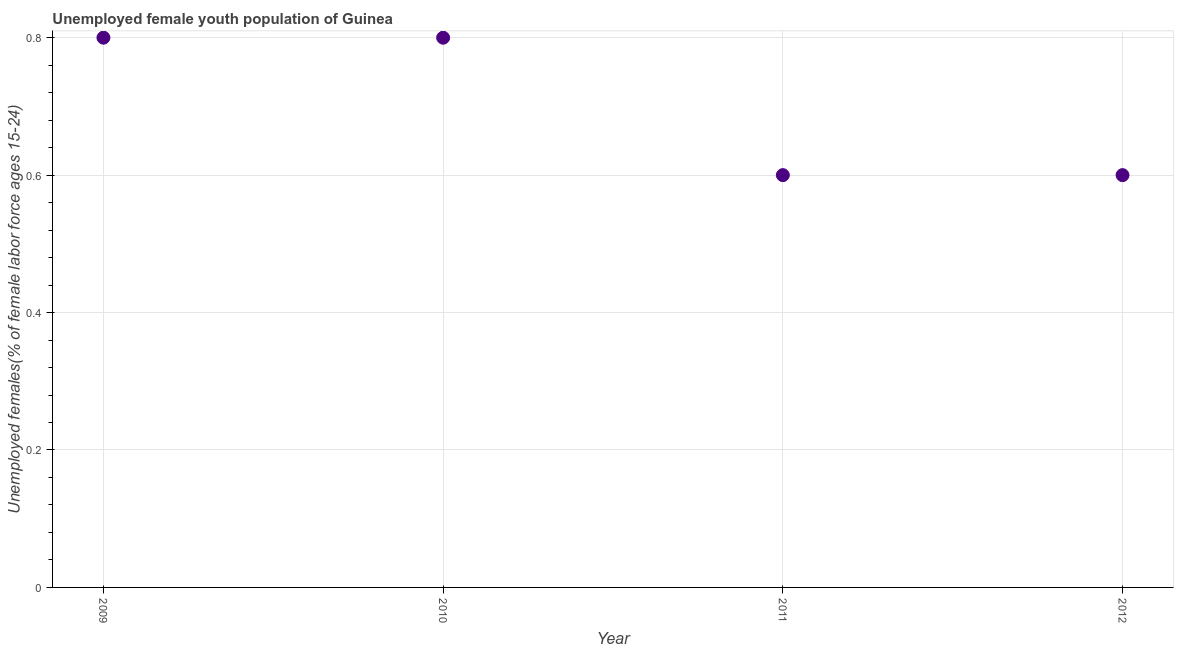What is the unemployed female youth in 2010?
Provide a short and direct response. 0.8. Across all years, what is the maximum unemployed female youth?
Your response must be concise. 0.8. Across all years, what is the minimum unemployed female youth?
Offer a terse response. 0.6. In which year was the unemployed female youth maximum?
Make the answer very short. 2009. In which year was the unemployed female youth minimum?
Keep it short and to the point. 2011. What is the sum of the unemployed female youth?
Your response must be concise. 2.8. What is the average unemployed female youth per year?
Your answer should be very brief. 0.7. What is the median unemployed female youth?
Keep it short and to the point. 0.7. In how many years, is the unemployed female youth greater than 0.2 %?
Provide a short and direct response. 4. Do a majority of the years between 2010 and 2011 (inclusive) have unemployed female youth greater than 0.6400000000000001 %?
Ensure brevity in your answer.  No. What is the ratio of the unemployed female youth in 2010 to that in 2012?
Make the answer very short. 1.33. Is the unemployed female youth in 2010 less than that in 2012?
Make the answer very short. No. What is the difference between the highest and the lowest unemployed female youth?
Provide a succinct answer. 0.2. In how many years, is the unemployed female youth greater than the average unemployed female youth taken over all years?
Provide a short and direct response. 2. Does the unemployed female youth monotonically increase over the years?
Offer a terse response. No. How many dotlines are there?
Offer a terse response. 1. How many years are there in the graph?
Your answer should be very brief. 4. What is the difference between two consecutive major ticks on the Y-axis?
Provide a succinct answer. 0.2. Are the values on the major ticks of Y-axis written in scientific E-notation?
Your answer should be very brief. No. Does the graph contain grids?
Provide a succinct answer. Yes. What is the title of the graph?
Provide a short and direct response. Unemployed female youth population of Guinea. What is the label or title of the Y-axis?
Give a very brief answer. Unemployed females(% of female labor force ages 15-24). What is the Unemployed females(% of female labor force ages 15-24) in 2009?
Keep it short and to the point. 0.8. What is the Unemployed females(% of female labor force ages 15-24) in 2010?
Offer a terse response. 0.8. What is the Unemployed females(% of female labor force ages 15-24) in 2011?
Make the answer very short. 0.6. What is the Unemployed females(% of female labor force ages 15-24) in 2012?
Provide a short and direct response. 0.6. What is the difference between the Unemployed females(% of female labor force ages 15-24) in 2009 and 2010?
Ensure brevity in your answer.  0. What is the difference between the Unemployed females(% of female labor force ages 15-24) in 2009 and 2011?
Provide a succinct answer. 0.2. What is the difference between the Unemployed females(% of female labor force ages 15-24) in 2011 and 2012?
Your response must be concise. 0. What is the ratio of the Unemployed females(% of female labor force ages 15-24) in 2009 to that in 2010?
Your answer should be compact. 1. What is the ratio of the Unemployed females(% of female labor force ages 15-24) in 2009 to that in 2011?
Provide a succinct answer. 1.33. What is the ratio of the Unemployed females(% of female labor force ages 15-24) in 2009 to that in 2012?
Your response must be concise. 1.33. What is the ratio of the Unemployed females(% of female labor force ages 15-24) in 2010 to that in 2011?
Provide a succinct answer. 1.33. What is the ratio of the Unemployed females(% of female labor force ages 15-24) in 2010 to that in 2012?
Provide a short and direct response. 1.33. What is the ratio of the Unemployed females(% of female labor force ages 15-24) in 2011 to that in 2012?
Provide a succinct answer. 1. 